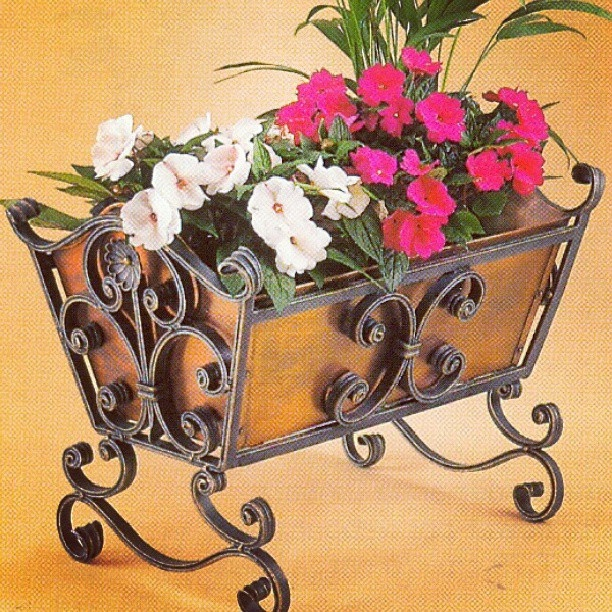Describe the objects in this image and their specific colors. I can see a potted plant in orange, gray, maroon, olive, and lightgray tones in this image. 